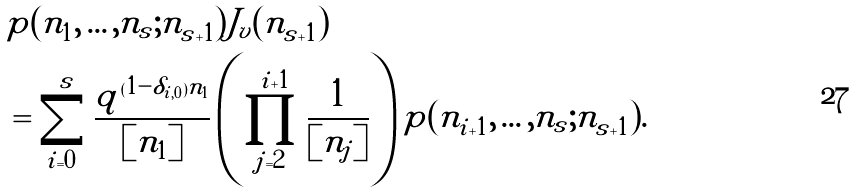Convert formula to latex. <formula><loc_0><loc_0><loc_500><loc_500>& p ( n _ { 1 } , \dots , n _ { s } ; n _ { s + 1 } ) J _ { v } ( n _ { s + 1 } ) \\ & = \sum _ { i = 0 } ^ { s } \frac { q ^ { ( 1 - \delta _ { i , 0 } ) n _ { 1 } } } { [ n _ { 1 } ] } \left ( \prod _ { j = 2 } ^ { i + 1 } \frac { 1 } { [ n _ { j } ] } \right ) p ( n _ { i + 1 } , \dots , n _ { s } ; n _ { s + 1 } ) .</formula> 